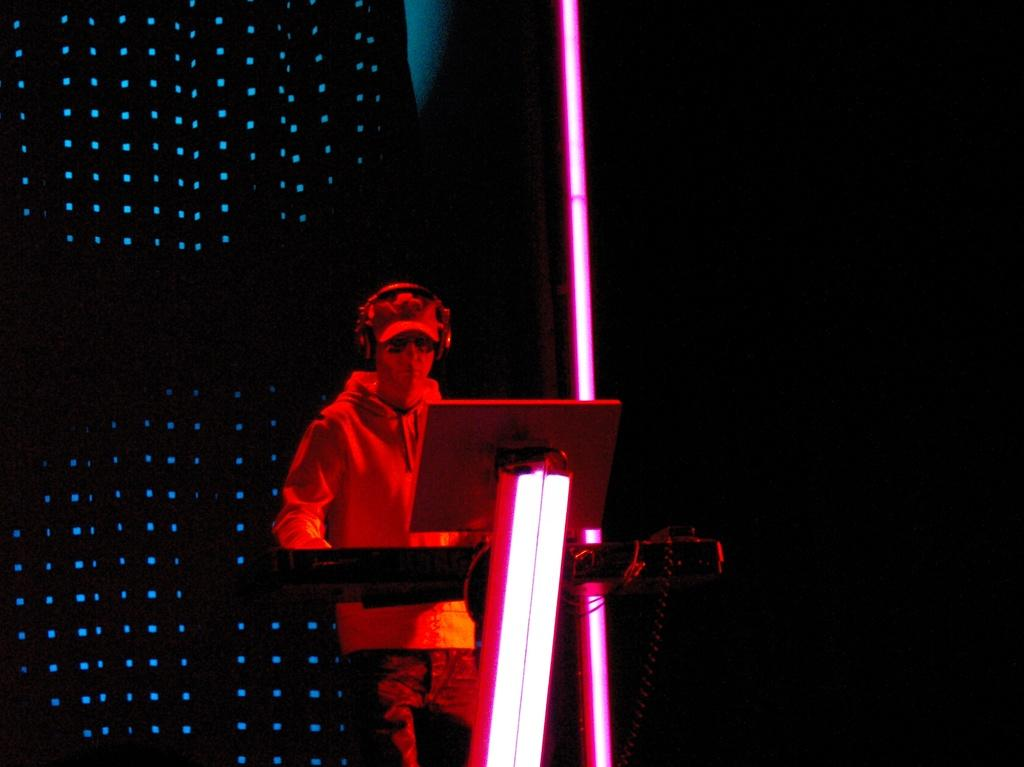What is the main subject of the image? There is a man standing in the center of the image. What object is in front of the man? There is a piano in front of the man. What electronic device is placed on a stand in front of the piano? A laptop is placed on a stand in front of the piano. What can be seen in the background of the image? There are lights visible in the background of the image. What type of writer is the man in the image? The image does not provide any information about the man being a writer, nor does it show any writing materials or activity. 